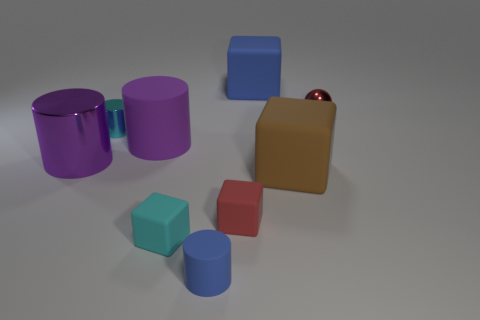What can you tell me about the largest object in the image? The largest object in the image is a purple cylinder. It's placed next to another cylinder of the same color but slightly shorter. These two purple cylinders are on the left-hand side of the frame, creating a visually interesting comparison of sizes. 